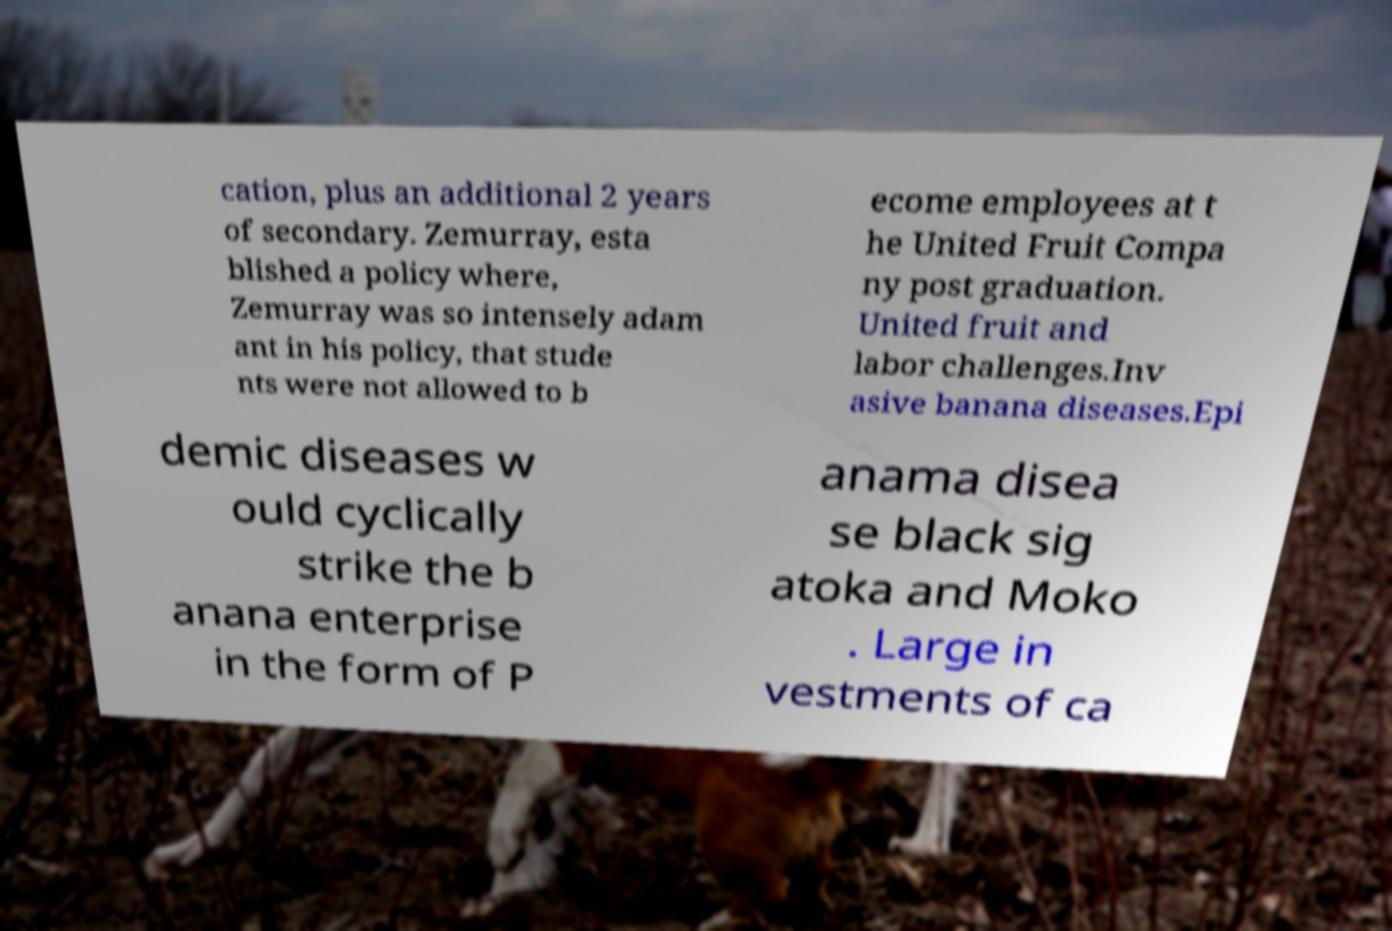Could you extract and type out the text from this image? cation, plus an additional 2 years of secondary. Zemurray, esta blished a policy where, Zemurray was so intensely adam ant in his policy, that stude nts were not allowed to b ecome employees at t he United Fruit Compa ny post graduation. United fruit and labor challenges.Inv asive banana diseases.Epi demic diseases w ould cyclically strike the b anana enterprise in the form of P anama disea se black sig atoka and Moko . Large in vestments of ca 